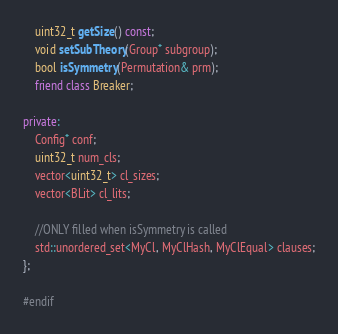<code> <loc_0><loc_0><loc_500><loc_500><_C++_>    uint32_t getSize() const;
    void setSubTheory(Group* subgroup);
    bool isSymmetry(Permutation& prm);
    friend class Breaker;

private:
    Config* conf;
    uint32_t num_cls;
    vector<uint32_t> cl_sizes;
    vector<BLit> cl_lits;

    //ONLY filled when isSymmetry is called
    std::unordered_set<MyCl, MyClHash, MyClEqual> clauses;
};

#endif
</code> 